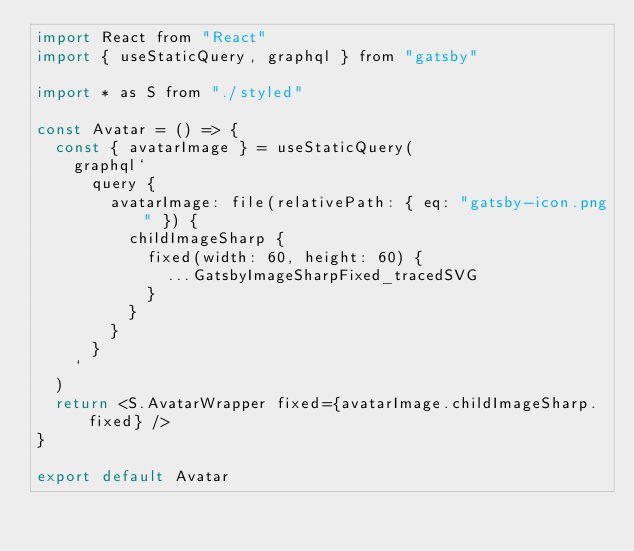<code> <loc_0><loc_0><loc_500><loc_500><_JavaScript_>import React from "React"
import { useStaticQuery, graphql } from "gatsby"

import * as S from "./styled"

const Avatar = () => {
  const { avatarImage } = useStaticQuery(
    graphql`
      query {
        avatarImage: file(relativePath: { eq: "gatsby-icon.png" }) {
          childImageSharp {
            fixed(width: 60, height: 60) {
              ...GatsbyImageSharpFixed_tracedSVG
            }
          }
        }
      }
    `
  )
  return <S.AvatarWrapper fixed={avatarImage.childImageSharp.fixed} />
}

export default Avatar
</code> 